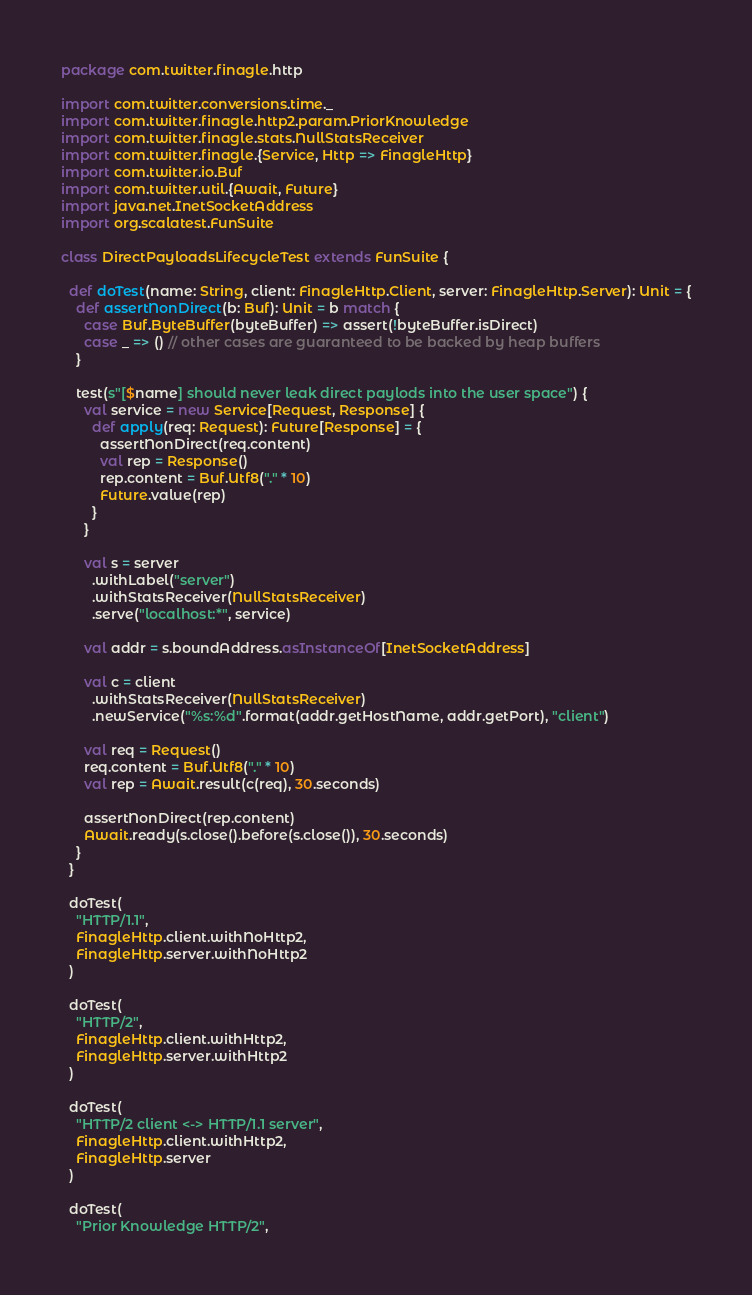Convert code to text. <code><loc_0><loc_0><loc_500><loc_500><_Scala_>package com.twitter.finagle.http

import com.twitter.conversions.time._
import com.twitter.finagle.http2.param.PriorKnowledge
import com.twitter.finagle.stats.NullStatsReceiver
import com.twitter.finagle.{Service, Http => FinagleHttp}
import com.twitter.io.Buf
import com.twitter.util.{Await, Future}
import java.net.InetSocketAddress
import org.scalatest.FunSuite

class DirectPayloadsLifecycleTest extends FunSuite {

  def doTest(name: String, client: FinagleHttp.Client, server: FinagleHttp.Server): Unit = {
    def assertNonDirect(b: Buf): Unit = b match {
      case Buf.ByteBuffer(byteBuffer) => assert(!byteBuffer.isDirect)
      case _ => () // other cases are guaranteed to be backed by heap buffers
    }

    test(s"[$name] should never leak direct paylods into the user space") {
      val service = new Service[Request, Response] {
        def apply(req: Request): Future[Response] = {
          assertNonDirect(req.content)
          val rep = Response()
          rep.content = Buf.Utf8("." * 10)
          Future.value(rep)
        }
      }

      val s = server
        .withLabel("server")
        .withStatsReceiver(NullStatsReceiver)
        .serve("localhost:*", service)

      val addr = s.boundAddress.asInstanceOf[InetSocketAddress]

      val c = client
        .withStatsReceiver(NullStatsReceiver)
        .newService("%s:%d".format(addr.getHostName, addr.getPort), "client")

      val req = Request()
      req.content = Buf.Utf8("." * 10)
      val rep = Await.result(c(req), 30.seconds)

      assertNonDirect(rep.content)
      Await.ready(s.close().before(s.close()), 30.seconds)
    }
  }

  doTest(
    "HTTP/1.1",
    FinagleHttp.client.withNoHttp2,
    FinagleHttp.server.withNoHttp2
  )

  doTest(
    "HTTP/2",
    FinagleHttp.client.withHttp2,
    FinagleHttp.server.withHttp2
  )

  doTest(
    "HTTP/2 client <-> HTTP/1.1 server",
    FinagleHttp.client.withHttp2,
    FinagleHttp.server
  )

  doTest(
    "Prior Knowledge HTTP/2",</code> 